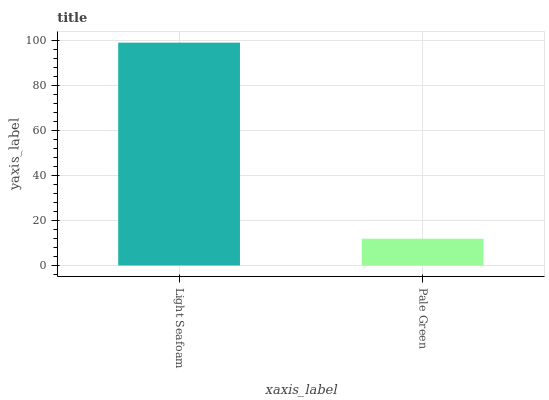Is Pale Green the minimum?
Answer yes or no. Yes. Is Light Seafoam the maximum?
Answer yes or no. Yes. Is Pale Green the maximum?
Answer yes or no. No. Is Light Seafoam greater than Pale Green?
Answer yes or no. Yes. Is Pale Green less than Light Seafoam?
Answer yes or no. Yes. Is Pale Green greater than Light Seafoam?
Answer yes or no. No. Is Light Seafoam less than Pale Green?
Answer yes or no. No. Is Light Seafoam the high median?
Answer yes or no. Yes. Is Pale Green the low median?
Answer yes or no. Yes. Is Pale Green the high median?
Answer yes or no. No. Is Light Seafoam the low median?
Answer yes or no. No. 